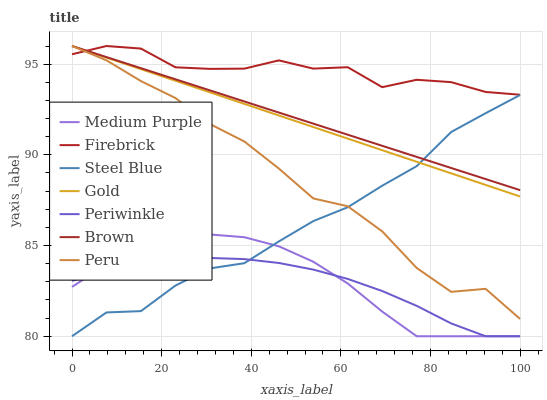Does Periwinkle have the minimum area under the curve?
Answer yes or no. Yes. Does Firebrick have the maximum area under the curve?
Answer yes or no. Yes. Does Gold have the minimum area under the curve?
Answer yes or no. No. Does Gold have the maximum area under the curve?
Answer yes or no. No. Is Gold the smoothest?
Answer yes or no. Yes. Is Peru the roughest?
Answer yes or no. Yes. Is Firebrick the smoothest?
Answer yes or no. No. Is Firebrick the roughest?
Answer yes or no. No. Does Gold have the lowest value?
Answer yes or no. No. Does Peru have the highest value?
Answer yes or no. Yes. Does Steel Blue have the highest value?
Answer yes or no. No. Is Steel Blue less than Firebrick?
Answer yes or no. Yes. Is Gold greater than Medium Purple?
Answer yes or no. Yes. Does Gold intersect Steel Blue?
Answer yes or no. Yes. Is Gold less than Steel Blue?
Answer yes or no. No. Is Gold greater than Steel Blue?
Answer yes or no. No. Does Steel Blue intersect Firebrick?
Answer yes or no. No. 